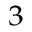<formula> <loc_0><loc_0><loc_500><loc_500>^ { 3 }</formula> 